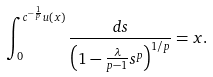Convert formula to latex. <formula><loc_0><loc_0><loc_500><loc_500>\int _ { 0 } ^ { c ^ { - \frac { 1 } { p } } u ( x ) } \frac { d s } { \left ( 1 - \frac { \lambda } { p - 1 } s ^ { p } \right ) ^ { 1 / p } } = x .</formula> 